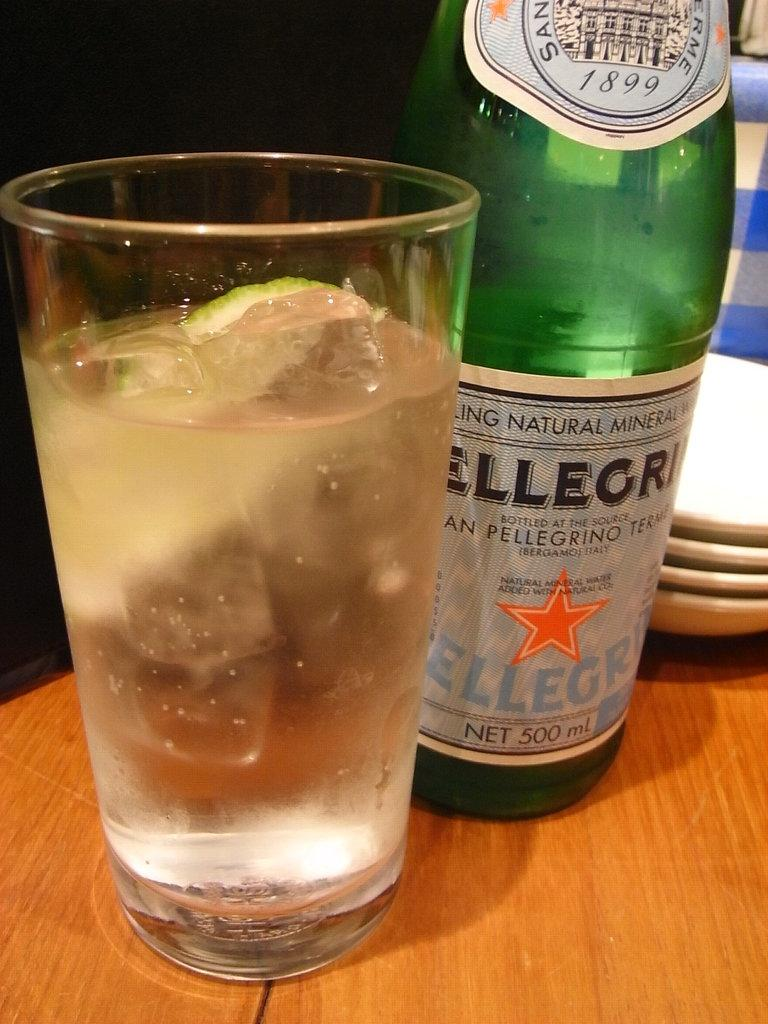<image>
Write a terse but informative summary of the picture. A glass of sparkling water sits next to a Pelligrino bottle. 